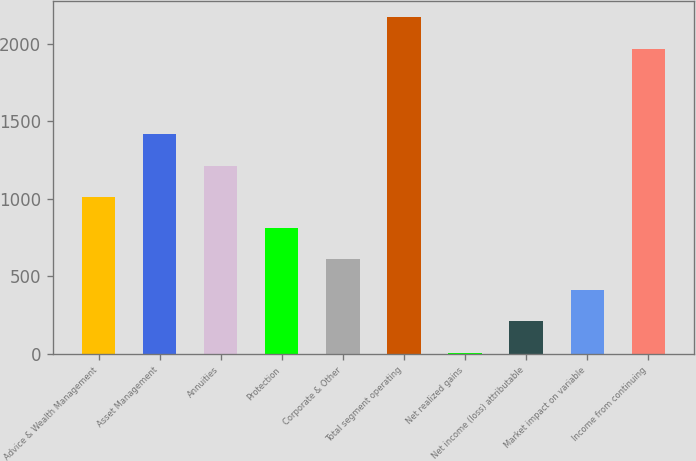Convert chart to OTSL. <chart><loc_0><loc_0><loc_500><loc_500><bar_chart><fcel>Advice & Wealth Management<fcel>Asset Management<fcel>Annuities<fcel>Protection<fcel>Corporate & Other<fcel>Total segment operating<fcel>Net realized gains<fcel>Net income (loss) attributable<fcel>Market impact on variable<fcel>Income from continuing<nl><fcel>1013<fcel>1415.4<fcel>1214.2<fcel>811.8<fcel>610.6<fcel>2171.2<fcel>7<fcel>208.2<fcel>409.4<fcel>1970<nl></chart> 